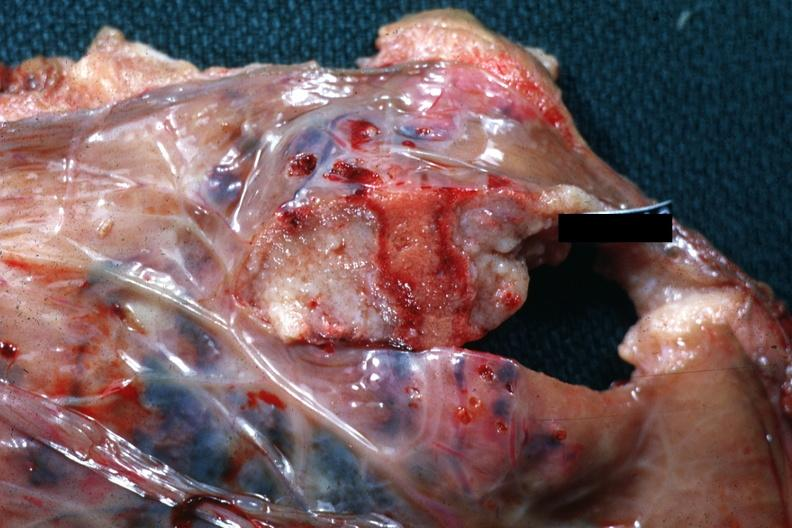where does this belong to?
Answer the question using a single word or phrase. Female reproductive system 